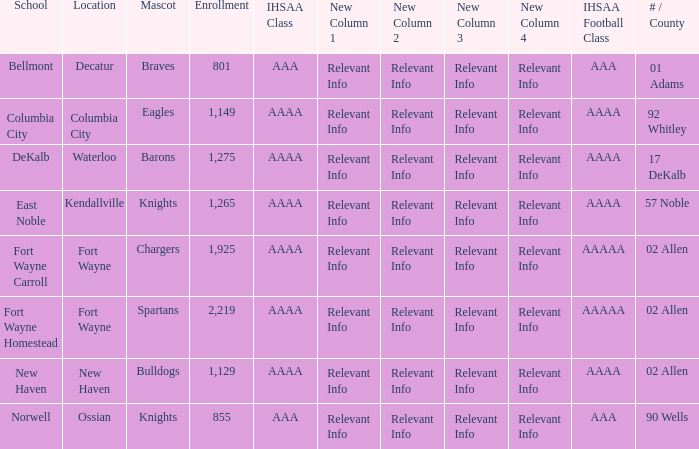What's the enrollment for Kendallville? 1265.0. 